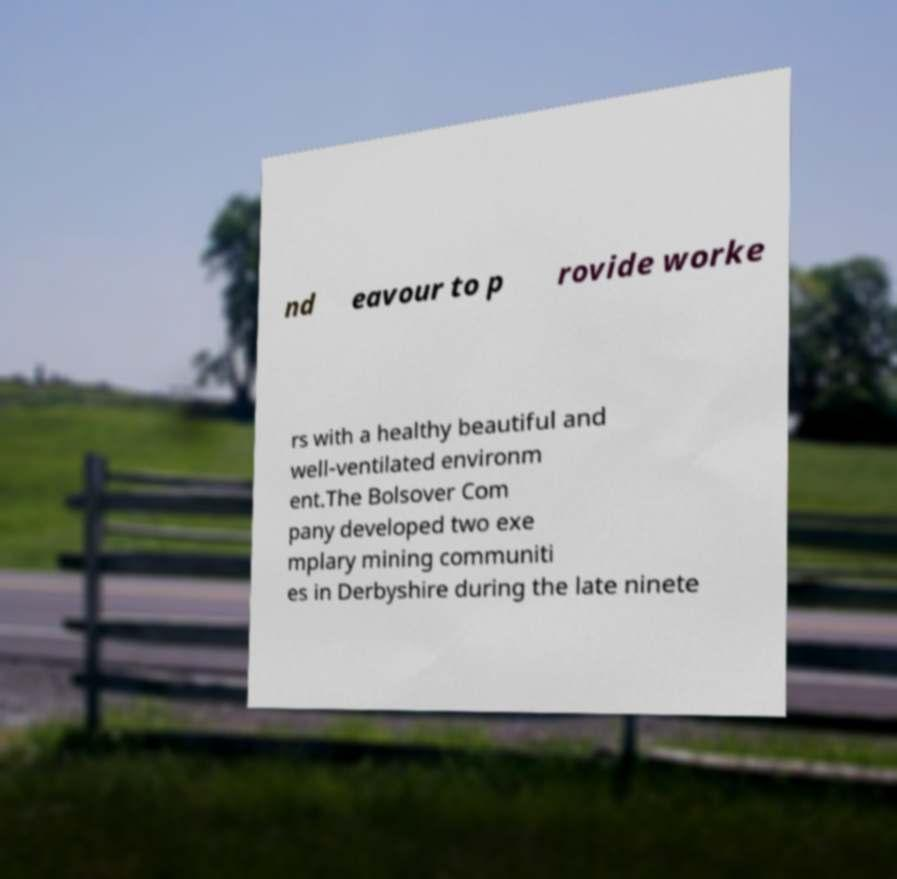I need the written content from this picture converted into text. Can you do that? nd eavour to p rovide worke rs with a healthy beautiful and well-ventilated environm ent.The Bolsover Com pany developed two exe mplary mining communiti es in Derbyshire during the late ninete 